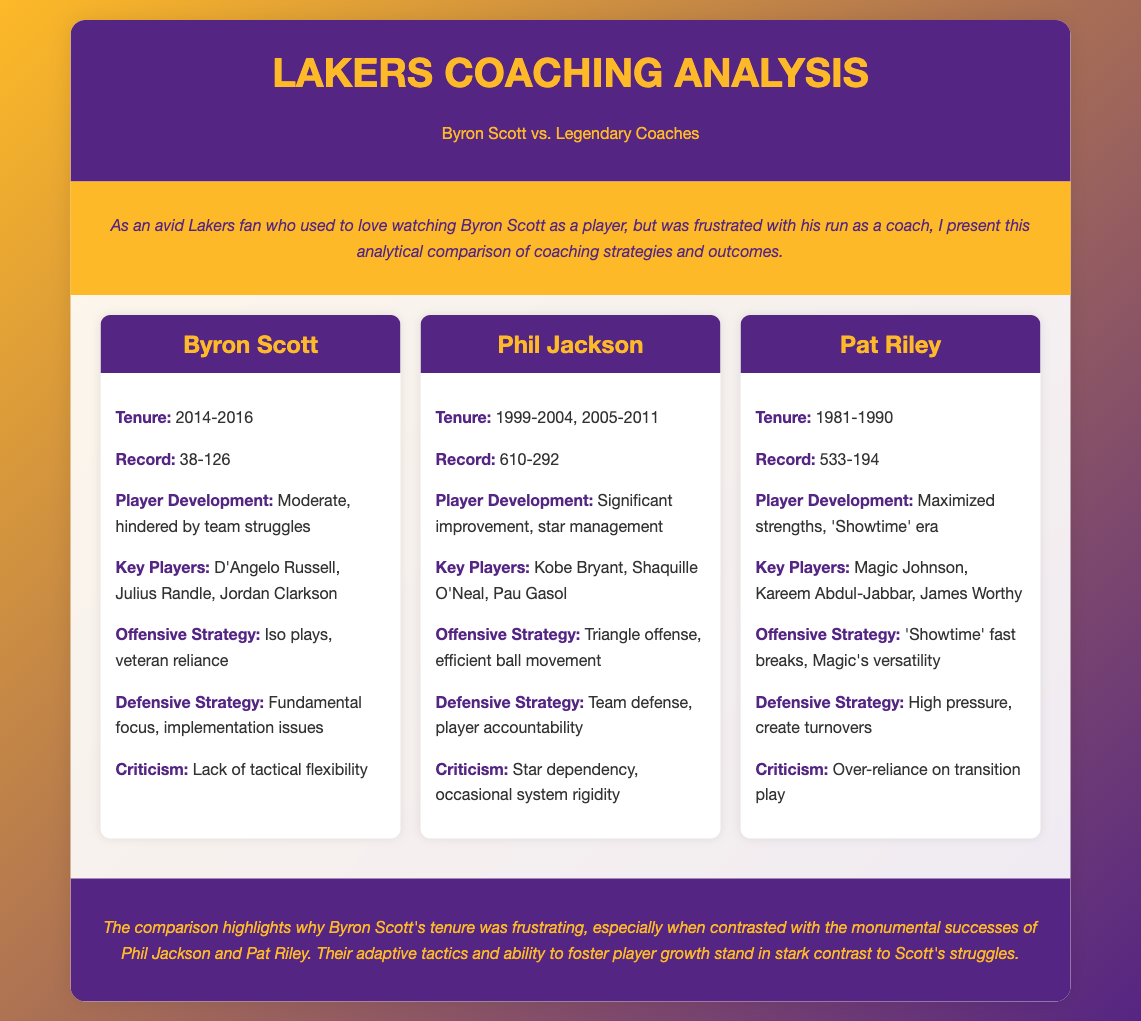What was Byron Scott's win-loss record? The document states Byron Scott's record as 38 wins and 126 losses during his tenure as coach.
Answer: 38-126 What years did Byron Scott coach the Lakers? The tenure of Byron Scott as head coach is noted as 2014 to 2016 in the document.
Answer: 2014-2016 What offensive strategy did Byron Scott primarily rely on? The document mentions that Byron Scott's offensive strategy focused on iso plays and veteran reliance.
Answer: Iso plays, veteran reliance How does Byron Scott's player development compare to Phil Jackson's? Byron Scott's player development is described as moderate and hindered by team struggles, while Phil Jackson is noted for significant improvement and star management.
Answer: Moderate, significant improvement What was Pat Riley's coaching record? Pat Riley's record during his coaching tenure is listed as 533 wins and 194 losses.
Answer: 533-194 What is a criticism mentioned about Byron Scott's coaching? The document highlights that a criticism of Byron Scott was his lack of tactical flexibility.
Answer: Lack of tactical flexibility What defensive strategy did Pat Riley employ? The document describes Pat Riley's defensive strategy as high pressure and creating turnovers.
Answer: High pressure, create turnovers Which key player is associated with Pat Riley? The document identifies Magic Johnson as one of the key players during Pat Riley's coaching period.
Answer: Magic Johnson What does the conclusion imply about Byron Scott's tenure? The conclusion suggests that Byron Scott's coaching tenure was frustrating in contrast to the successes of Phil Jackson and Pat Riley.
Answer: Frustrating contrast to Jackson and Riley 